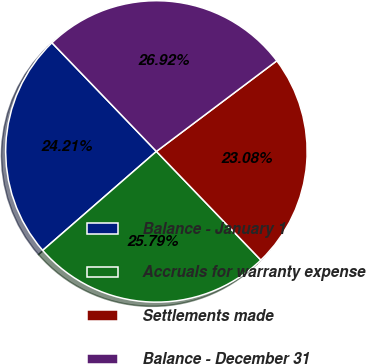Convert chart to OTSL. <chart><loc_0><loc_0><loc_500><loc_500><pie_chart><fcel>Balance - January 1<fcel>Accruals for warranty expense<fcel>Settlements made<fcel>Balance - December 31<nl><fcel>24.21%<fcel>25.79%<fcel>23.08%<fcel>26.92%<nl></chart> 